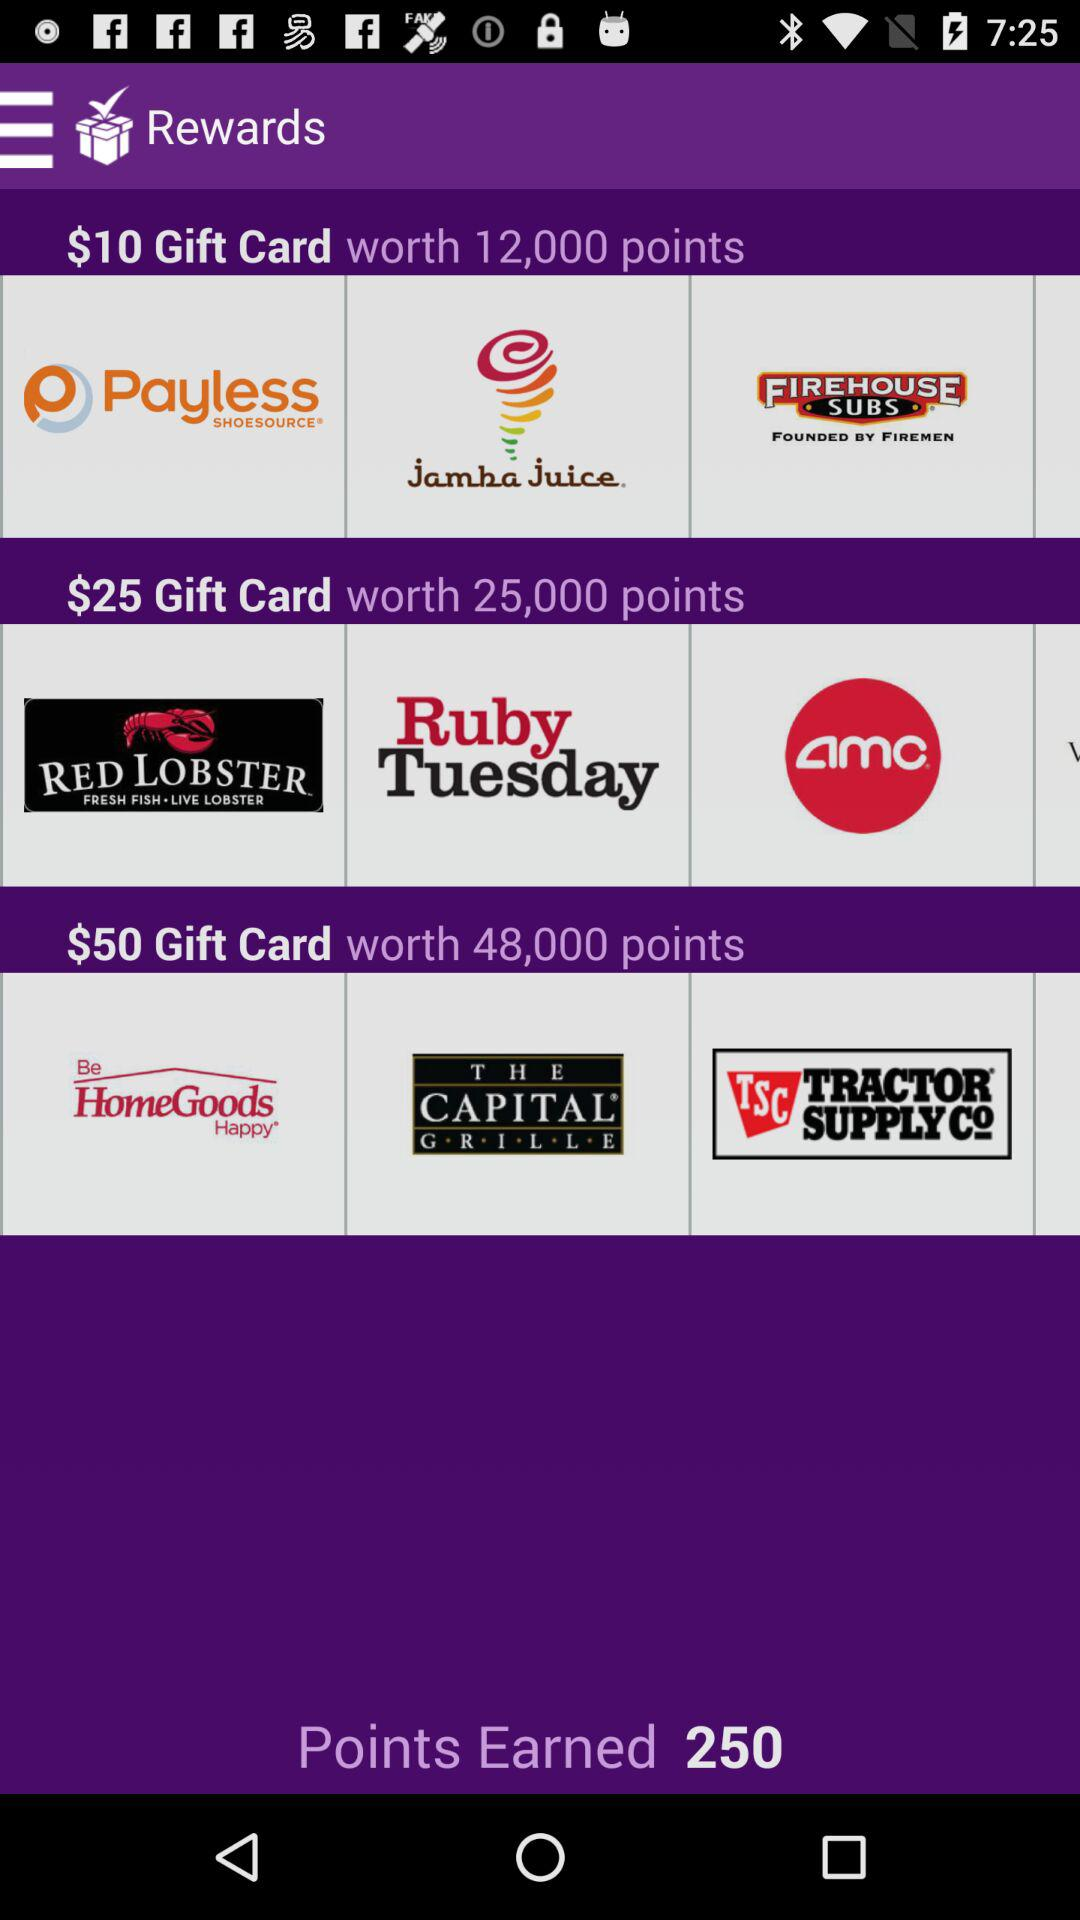How many points are needed to redeem the $25 gift card?
Answer the question using a single word or phrase. 25,000 